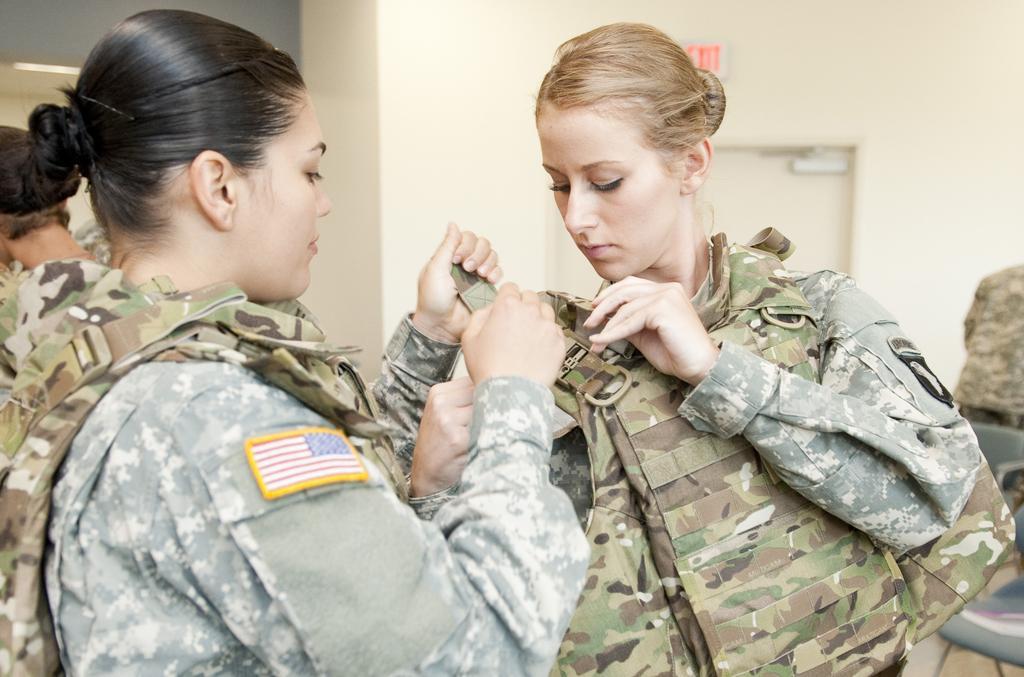Could you give a brief overview of what you see in this image? At the front of the image there are two ladies with a uniform. Behind them there is a wall with door and sign board. 